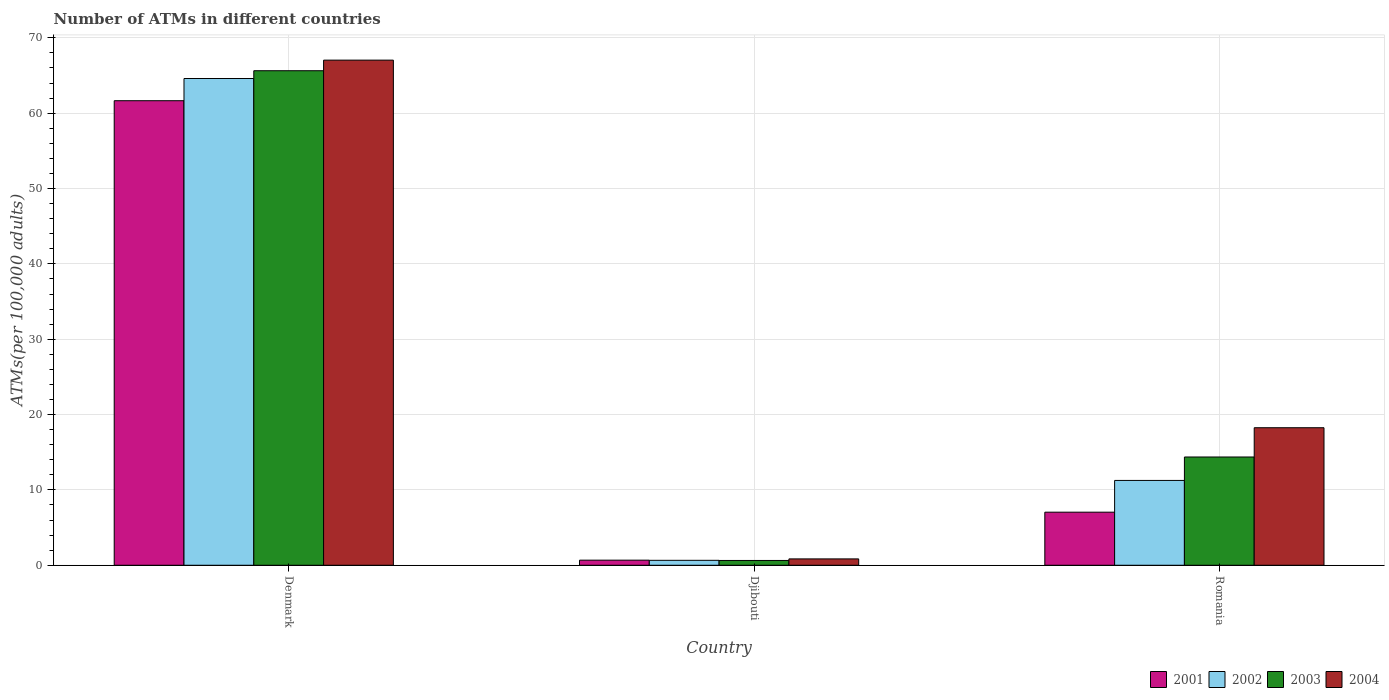How many different coloured bars are there?
Your response must be concise. 4. How many groups of bars are there?
Keep it short and to the point. 3. Are the number of bars on each tick of the X-axis equal?
Your response must be concise. Yes. How many bars are there on the 1st tick from the left?
Offer a very short reply. 4. How many bars are there on the 2nd tick from the right?
Your response must be concise. 4. What is the label of the 1st group of bars from the left?
Give a very brief answer. Denmark. In how many cases, is the number of bars for a given country not equal to the number of legend labels?
Make the answer very short. 0. What is the number of ATMs in 2003 in Denmark?
Offer a very short reply. 65.64. Across all countries, what is the maximum number of ATMs in 2002?
Keep it short and to the point. 64.61. Across all countries, what is the minimum number of ATMs in 2004?
Offer a very short reply. 0.84. In which country was the number of ATMs in 2004 minimum?
Provide a succinct answer. Djibouti. What is the total number of ATMs in 2002 in the graph?
Provide a short and direct response. 76.52. What is the difference between the number of ATMs in 2002 in Denmark and that in Romania?
Give a very brief answer. 53.35. What is the difference between the number of ATMs in 2004 in Romania and the number of ATMs in 2003 in Djibouti?
Give a very brief answer. 17.62. What is the average number of ATMs in 2002 per country?
Your answer should be very brief. 25.51. What is the difference between the number of ATMs of/in 2001 and number of ATMs of/in 2004 in Djibouti?
Ensure brevity in your answer.  -0.17. What is the ratio of the number of ATMs in 2004 in Denmark to that in Djibouti?
Provide a succinct answer. 79.46. Is the number of ATMs in 2002 in Denmark less than that in Djibouti?
Make the answer very short. No. What is the difference between the highest and the second highest number of ATMs in 2002?
Give a very brief answer. 63.95. What is the difference between the highest and the lowest number of ATMs in 2003?
Keep it short and to the point. 65. In how many countries, is the number of ATMs in 2003 greater than the average number of ATMs in 2003 taken over all countries?
Make the answer very short. 1. Is the sum of the number of ATMs in 2003 in Denmark and Djibouti greater than the maximum number of ATMs in 2002 across all countries?
Offer a terse response. Yes. What does the 2nd bar from the left in Djibouti represents?
Provide a succinct answer. 2002. Is it the case that in every country, the sum of the number of ATMs in 2002 and number of ATMs in 2004 is greater than the number of ATMs in 2001?
Offer a very short reply. Yes. Are all the bars in the graph horizontal?
Ensure brevity in your answer.  No. Does the graph contain any zero values?
Make the answer very short. No. Does the graph contain grids?
Provide a short and direct response. Yes. How many legend labels are there?
Make the answer very short. 4. How are the legend labels stacked?
Provide a succinct answer. Horizontal. What is the title of the graph?
Give a very brief answer. Number of ATMs in different countries. Does "1993" appear as one of the legend labels in the graph?
Your answer should be very brief. No. What is the label or title of the X-axis?
Your response must be concise. Country. What is the label or title of the Y-axis?
Provide a succinct answer. ATMs(per 100,0 adults). What is the ATMs(per 100,000 adults) of 2001 in Denmark?
Offer a terse response. 61.66. What is the ATMs(per 100,000 adults) in 2002 in Denmark?
Give a very brief answer. 64.61. What is the ATMs(per 100,000 adults) in 2003 in Denmark?
Provide a short and direct response. 65.64. What is the ATMs(per 100,000 adults) in 2004 in Denmark?
Make the answer very short. 67.04. What is the ATMs(per 100,000 adults) of 2001 in Djibouti?
Make the answer very short. 0.68. What is the ATMs(per 100,000 adults) of 2002 in Djibouti?
Your answer should be compact. 0.66. What is the ATMs(per 100,000 adults) in 2003 in Djibouti?
Give a very brief answer. 0.64. What is the ATMs(per 100,000 adults) of 2004 in Djibouti?
Your answer should be very brief. 0.84. What is the ATMs(per 100,000 adults) of 2001 in Romania?
Keep it short and to the point. 7.04. What is the ATMs(per 100,000 adults) in 2002 in Romania?
Offer a terse response. 11.26. What is the ATMs(per 100,000 adults) in 2003 in Romania?
Give a very brief answer. 14.37. What is the ATMs(per 100,000 adults) of 2004 in Romania?
Your answer should be compact. 18.26. Across all countries, what is the maximum ATMs(per 100,000 adults) in 2001?
Your answer should be compact. 61.66. Across all countries, what is the maximum ATMs(per 100,000 adults) of 2002?
Provide a succinct answer. 64.61. Across all countries, what is the maximum ATMs(per 100,000 adults) in 2003?
Provide a succinct answer. 65.64. Across all countries, what is the maximum ATMs(per 100,000 adults) in 2004?
Ensure brevity in your answer.  67.04. Across all countries, what is the minimum ATMs(per 100,000 adults) of 2001?
Make the answer very short. 0.68. Across all countries, what is the minimum ATMs(per 100,000 adults) of 2002?
Make the answer very short. 0.66. Across all countries, what is the minimum ATMs(per 100,000 adults) in 2003?
Offer a terse response. 0.64. Across all countries, what is the minimum ATMs(per 100,000 adults) in 2004?
Your answer should be very brief. 0.84. What is the total ATMs(per 100,000 adults) of 2001 in the graph?
Your answer should be very brief. 69.38. What is the total ATMs(per 100,000 adults) in 2002 in the graph?
Offer a very short reply. 76.52. What is the total ATMs(per 100,000 adults) of 2003 in the graph?
Offer a terse response. 80.65. What is the total ATMs(per 100,000 adults) in 2004 in the graph?
Provide a succinct answer. 86.14. What is the difference between the ATMs(per 100,000 adults) of 2001 in Denmark and that in Djibouti?
Keep it short and to the point. 60.98. What is the difference between the ATMs(per 100,000 adults) in 2002 in Denmark and that in Djibouti?
Give a very brief answer. 63.95. What is the difference between the ATMs(per 100,000 adults) in 2003 in Denmark and that in Djibouti?
Give a very brief answer. 65. What is the difference between the ATMs(per 100,000 adults) in 2004 in Denmark and that in Djibouti?
Keep it short and to the point. 66.2. What is the difference between the ATMs(per 100,000 adults) in 2001 in Denmark and that in Romania?
Your answer should be compact. 54.61. What is the difference between the ATMs(per 100,000 adults) in 2002 in Denmark and that in Romania?
Offer a terse response. 53.35. What is the difference between the ATMs(per 100,000 adults) of 2003 in Denmark and that in Romania?
Your answer should be very brief. 51.27. What is the difference between the ATMs(per 100,000 adults) in 2004 in Denmark and that in Romania?
Your answer should be very brief. 48.79. What is the difference between the ATMs(per 100,000 adults) in 2001 in Djibouti and that in Romania?
Provide a succinct answer. -6.37. What is the difference between the ATMs(per 100,000 adults) in 2002 in Djibouti and that in Romania?
Your response must be concise. -10.6. What is the difference between the ATMs(per 100,000 adults) in 2003 in Djibouti and that in Romania?
Make the answer very short. -13.73. What is the difference between the ATMs(per 100,000 adults) in 2004 in Djibouti and that in Romania?
Provide a short and direct response. -17.41. What is the difference between the ATMs(per 100,000 adults) in 2001 in Denmark and the ATMs(per 100,000 adults) in 2002 in Djibouti?
Ensure brevity in your answer.  61. What is the difference between the ATMs(per 100,000 adults) in 2001 in Denmark and the ATMs(per 100,000 adults) in 2003 in Djibouti?
Ensure brevity in your answer.  61.02. What is the difference between the ATMs(per 100,000 adults) of 2001 in Denmark and the ATMs(per 100,000 adults) of 2004 in Djibouti?
Ensure brevity in your answer.  60.81. What is the difference between the ATMs(per 100,000 adults) in 2002 in Denmark and the ATMs(per 100,000 adults) in 2003 in Djibouti?
Your answer should be very brief. 63.97. What is the difference between the ATMs(per 100,000 adults) in 2002 in Denmark and the ATMs(per 100,000 adults) in 2004 in Djibouti?
Provide a succinct answer. 63.76. What is the difference between the ATMs(per 100,000 adults) of 2003 in Denmark and the ATMs(per 100,000 adults) of 2004 in Djibouti?
Your answer should be very brief. 64.79. What is the difference between the ATMs(per 100,000 adults) in 2001 in Denmark and the ATMs(per 100,000 adults) in 2002 in Romania?
Ensure brevity in your answer.  50.4. What is the difference between the ATMs(per 100,000 adults) of 2001 in Denmark and the ATMs(per 100,000 adults) of 2003 in Romania?
Provide a short and direct response. 47.29. What is the difference between the ATMs(per 100,000 adults) of 2001 in Denmark and the ATMs(per 100,000 adults) of 2004 in Romania?
Offer a terse response. 43.4. What is the difference between the ATMs(per 100,000 adults) in 2002 in Denmark and the ATMs(per 100,000 adults) in 2003 in Romania?
Make the answer very short. 50.24. What is the difference between the ATMs(per 100,000 adults) in 2002 in Denmark and the ATMs(per 100,000 adults) in 2004 in Romania?
Offer a terse response. 46.35. What is the difference between the ATMs(per 100,000 adults) in 2003 in Denmark and the ATMs(per 100,000 adults) in 2004 in Romania?
Provide a short and direct response. 47.38. What is the difference between the ATMs(per 100,000 adults) of 2001 in Djibouti and the ATMs(per 100,000 adults) of 2002 in Romania?
Give a very brief answer. -10.58. What is the difference between the ATMs(per 100,000 adults) in 2001 in Djibouti and the ATMs(per 100,000 adults) in 2003 in Romania?
Offer a terse response. -13.69. What is the difference between the ATMs(per 100,000 adults) in 2001 in Djibouti and the ATMs(per 100,000 adults) in 2004 in Romania?
Offer a terse response. -17.58. What is the difference between the ATMs(per 100,000 adults) in 2002 in Djibouti and the ATMs(per 100,000 adults) in 2003 in Romania?
Your answer should be very brief. -13.71. What is the difference between the ATMs(per 100,000 adults) of 2002 in Djibouti and the ATMs(per 100,000 adults) of 2004 in Romania?
Provide a succinct answer. -17.6. What is the difference between the ATMs(per 100,000 adults) of 2003 in Djibouti and the ATMs(per 100,000 adults) of 2004 in Romania?
Keep it short and to the point. -17.62. What is the average ATMs(per 100,000 adults) in 2001 per country?
Ensure brevity in your answer.  23.13. What is the average ATMs(per 100,000 adults) in 2002 per country?
Give a very brief answer. 25.51. What is the average ATMs(per 100,000 adults) in 2003 per country?
Provide a short and direct response. 26.88. What is the average ATMs(per 100,000 adults) in 2004 per country?
Provide a succinct answer. 28.71. What is the difference between the ATMs(per 100,000 adults) in 2001 and ATMs(per 100,000 adults) in 2002 in Denmark?
Offer a very short reply. -2.95. What is the difference between the ATMs(per 100,000 adults) in 2001 and ATMs(per 100,000 adults) in 2003 in Denmark?
Make the answer very short. -3.98. What is the difference between the ATMs(per 100,000 adults) of 2001 and ATMs(per 100,000 adults) of 2004 in Denmark?
Give a very brief answer. -5.39. What is the difference between the ATMs(per 100,000 adults) in 2002 and ATMs(per 100,000 adults) in 2003 in Denmark?
Your answer should be very brief. -1.03. What is the difference between the ATMs(per 100,000 adults) in 2002 and ATMs(per 100,000 adults) in 2004 in Denmark?
Your answer should be very brief. -2.44. What is the difference between the ATMs(per 100,000 adults) of 2003 and ATMs(per 100,000 adults) of 2004 in Denmark?
Provide a short and direct response. -1.41. What is the difference between the ATMs(per 100,000 adults) in 2001 and ATMs(per 100,000 adults) in 2002 in Djibouti?
Your answer should be compact. 0.02. What is the difference between the ATMs(per 100,000 adults) of 2001 and ATMs(per 100,000 adults) of 2003 in Djibouti?
Your answer should be very brief. 0.04. What is the difference between the ATMs(per 100,000 adults) of 2001 and ATMs(per 100,000 adults) of 2004 in Djibouti?
Your answer should be compact. -0.17. What is the difference between the ATMs(per 100,000 adults) of 2002 and ATMs(per 100,000 adults) of 2003 in Djibouti?
Your response must be concise. 0.02. What is the difference between the ATMs(per 100,000 adults) in 2002 and ATMs(per 100,000 adults) in 2004 in Djibouti?
Your answer should be very brief. -0.19. What is the difference between the ATMs(per 100,000 adults) in 2003 and ATMs(per 100,000 adults) in 2004 in Djibouti?
Keep it short and to the point. -0.21. What is the difference between the ATMs(per 100,000 adults) in 2001 and ATMs(per 100,000 adults) in 2002 in Romania?
Your response must be concise. -4.21. What is the difference between the ATMs(per 100,000 adults) in 2001 and ATMs(per 100,000 adults) in 2003 in Romania?
Give a very brief answer. -7.32. What is the difference between the ATMs(per 100,000 adults) of 2001 and ATMs(per 100,000 adults) of 2004 in Romania?
Make the answer very short. -11.21. What is the difference between the ATMs(per 100,000 adults) of 2002 and ATMs(per 100,000 adults) of 2003 in Romania?
Your response must be concise. -3.11. What is the difference between the ATMs(per 100,000 adults) of 2002 and ATMs(per 100,000 adults) of 2004 in Romania?
Make the answer very short. -7. What is the difference between the ATMs(per 100,000 adults) in 2003 and ATMs(per 100,000 adults) in 2004 in Romania?
Make the answer very short. -3.89. What is the ratio of the ATMs(per 100,000 adults) of 2001 in Denmark to that in Djibouti?
Provide a short and direct response. 91.18. What is the ratio of the ATMs(per 100,000 adults) in 2002 in Denmark to that in Djibouti?
Your answer should be compact. 98.45. What is the ratio of the ATMs(per 100,000 adults) of 2003 in Denmark to that in Djibouti?
Offer a terse response. 102.88. What is the ratio of the ATMs(per 100,000 adults) of 2004 in Denmark to that in Djibouti?
Provide a short and direct response. 79.46. What is the ratio of the ATMs(per 100,000 adults) in 2001 in Denmark to that in Romania?
Make the answer very short. 8.75. What is the ratio of the ATMs(per 100,000 adults) in 2002 in Denmark to that in Romania?
Keep it short and to the point. 5.74. What is the ratio of the ATMs(per 100,000 adults) in 2003 in Denmark to that in Romania?
Your answer should be compact. 4.57. What is the ratio of the ATMs(per 100,000 adults) of 2004 in Denmark to that in Romania?
Offer a very short reply. 3.67. What is the ratio of the ATMs(per 100,000 adults) in 2001 in Djibouti to that in Romania?
Ensure brevity in your answer.  0.1. What is the ratio of the ATMs(per 100,000 adults) of 2002 in Djibouti to that in Romania?
Offer a very short reply. 0.06. What is the ratio of the ATMs(per 100,000 adults) in 2003 in Djibouti to that in Romania?
Ensure brevity in your answer.  0.04. What is the ratio of the ATMs(per 100,000 adults) of 2004 in Djibouti to that in Romania?
Make the answer very short. 0.05. What is the difference between the highest and the second highest ATMs(per 100,000 adults) of 2001?
Offer a very short reply. 54.61. What is the difference between the highest and the second highest ATMs(per 100,000 adults) of 2002?
Offer a very short reply. 53.35. What is the difference between the highest and the second highest ATMs(per 100,000 adults) in 2003?
Your answer should be compact. 51.27. What is the difference between the highest and the second highest ATMs(per 100,000 adults) in 2004?
Your response must be concise. 48.79. What is the difference between the highest and the lowest ATMs(per 100,000 adults) of 2001?
Provide a short and direct response. 60.98. What is the difference between the highest and the lowest ATMs(per 100,000 adults) in 2002?
Make the answer very short. 63.95. What is the difference between the highest and the lowest ATMs(per 100,000 adults) of 2003?
Make the answer very short. 65. What is the difference between the highest and the lowest ATMs(per 100,000 adults) of 2004?
Offer a terse response. 66.2. 